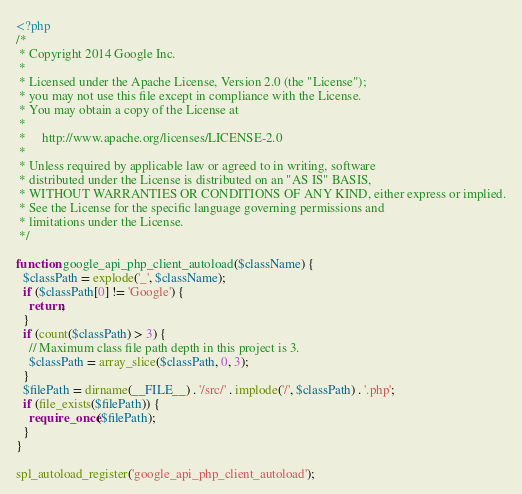Convert code to text. <code><loc_0><loc_0><loc_500><loc_500><_PHP_><?php
/*
 * Copyright 2014 Google Inc.
 *
 * Licensed under the Apache License, Version 2.0 (the "License");
 * you may not use this file except in compliance with the License.
 * You may obtain a copy of the License at
 *
 *     http://www.apache.org/licenses/LICENSE-2.0
 *
 * Unless required by applicable law or agreed to in writing, software
 * distributed under the License is distributed on an "AS IS" BASIS,
 * WITHOUT WARRANTIES OR CONDITIONS OF ANY KIND, either express or implied.
 * See the License for the specific language governing permissions and
 * limitations under the License.
 */

function google_api_php_client_autoload($className) {
  $classPath = explode('_', $className);
  if ($classPath[0] != 'Google') {
    return;
  }
  if (count($classPath) > 3) {
    // Maximum class file path depth in this project is 3.
    $classPath = array_slice($classPath, 0, 3);
  }
  $filePath = dirname(__FILE__) . '/src/' . implode('/', $classPath) . '.php';
  if (file_exists($filePath)) {
    require_once($filePath);
  }
}

spl_autoload_register('google_api_php_client_autoload');
</code> 